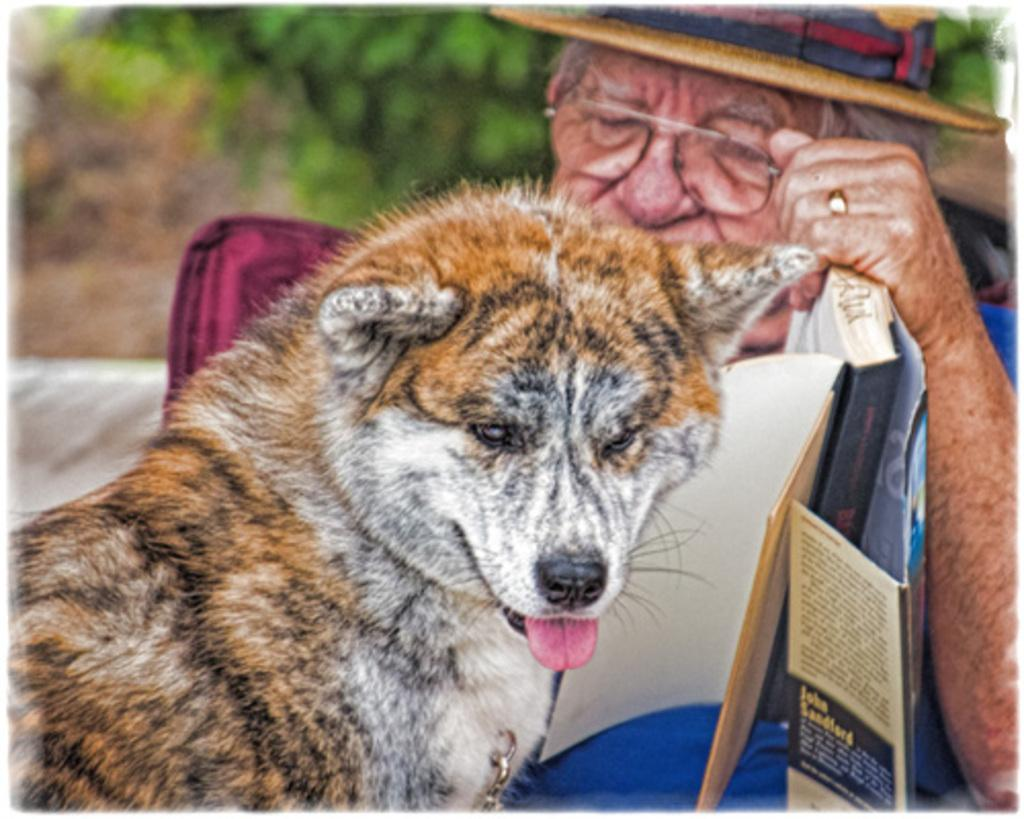What type of animal is in the image? There is a dog in the image. Who else is in the image besides the dog? There is a man in the image. Where are the dog and man located in the image? The dog and man are in the middle of the image. What can be seen in the background of the image? There is greenery in the background of the image. What type of tin can be seen in the image? There is no tin present in the image. How many deer are visible in the image? There are no deer present in the image. 